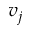<formula> <loc_0><loc_0><loc_500><loc_500>v _ { j }</formula> 